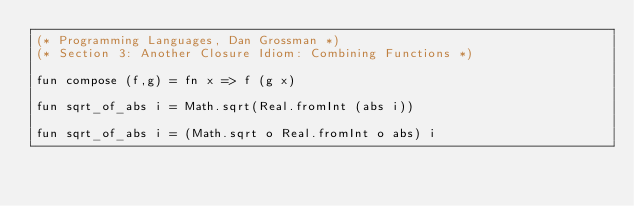<code> <loc_0><loc_0><loc_500><loc_500><_SML_>(* Programming Languages, Dan Grossman *)
(* Section 3: Another Closure Idiom: Combining Functions *)

fun compose (f,g) = fn x => f (g x)

fun sqrt_of_abs i = Math.sqrt(Real.fromInt (abs i))

fun sqrt_of_abs i = (Math.sqrt o Real.fromInt o abs) i
</code> 